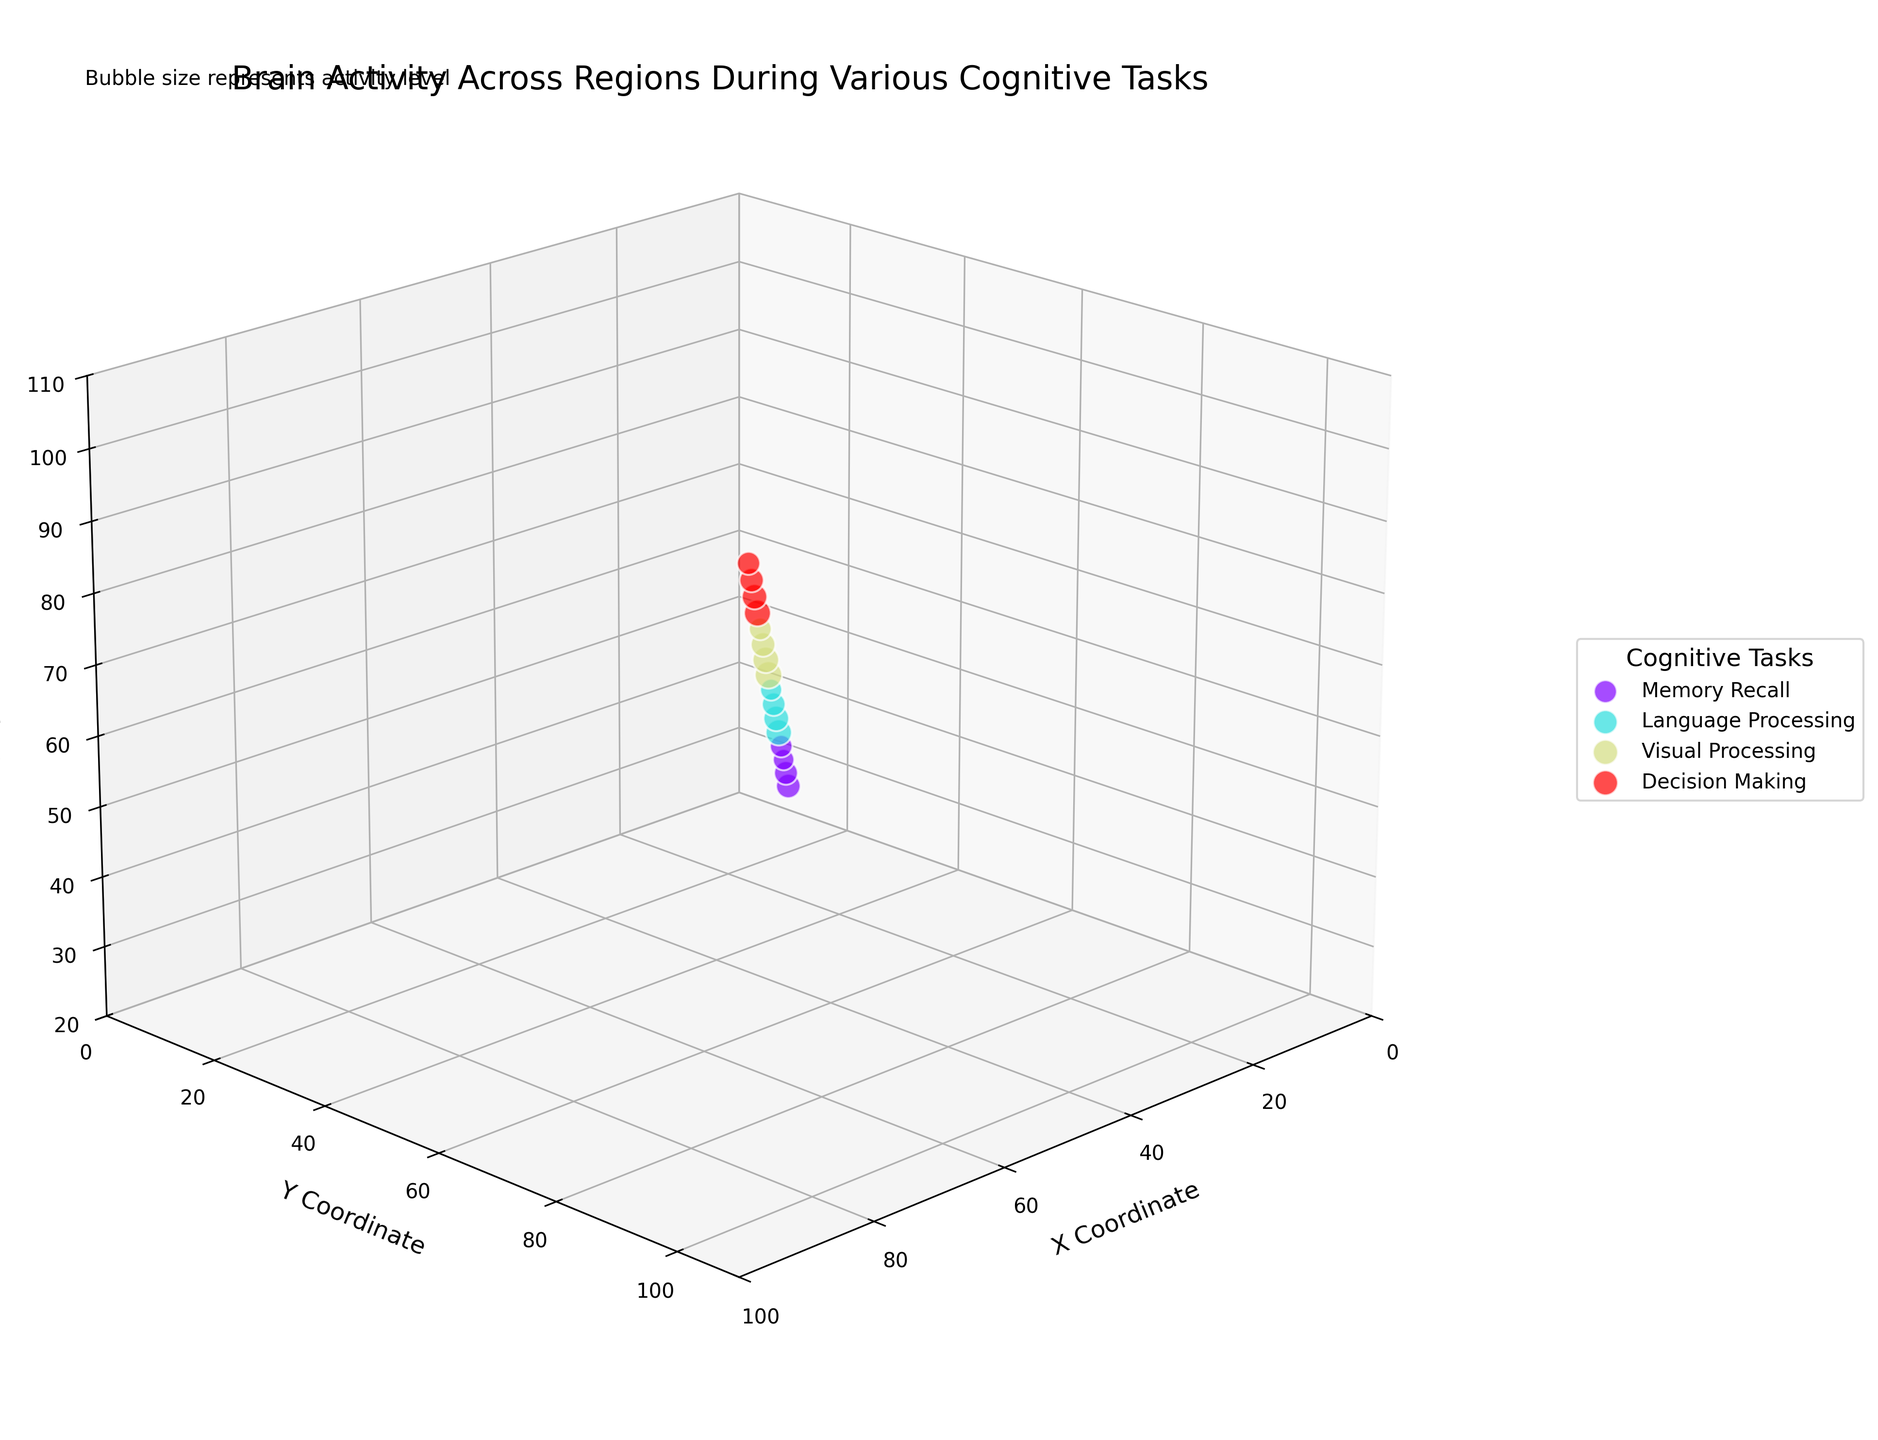What's the title of the figure? The title is located at the top of the figure and reads "Brain Activity Across Regions During Various Cognitive Tasks".
Answer: Brain Activity Across Regions During Various Cognitive Tasks What three axes are labeled on the plot? The three axes are labeled as "X Coordinate", "Y Coordinate", and "Z Coordinate", which can be found along the axes themselves in the figure.
Answer: X Coordinate, Y Coordinate, and Z Coordinate What task shows the highest activity level? By observing the bubble sizes in the scatter plot, the largest bubble represents the highest activity level. The bubble at (50, 60, 70) in the Visual Processing task with Occipital Lobe indicates the highest activity level of 9.1.
Answer: Visual Processing Which cognitive task has the most represented brain regions? By counting the bubbles for each cognitive task, the tasks are Memory Recall with 4 regions, Language Processing with 4 regions, Visual Processing with 4 regions, and Decision Making with 4 regions. All tasks are equally represented with 4 regions each.
Answer: Memory Recall, Language Processing, Visual Processing, and Decision Making Which specific region in the Prefrontal Cortex has higher activity, Memory Recall or Decision Making? By comparing the Activity values, Memory Recall has an activity level of 6.8 in the Prefrontal Cortex, while Decision Making has 8.7 in the same region. Since 8.7 > 6.8, the Prefrontal Cortex during Decision Making shows higher activity.
Answer: Decision Making What's the average activity level for the Temporal Lobe across different tasks? By summing up the activity levels of the Temporal Lobe across all tasks [(6.1 for Memory Recall) + (5.8 for Language Processing) + (6.2 for Visual Processing)] and dividing by the number of occurrences (3), the average activity level is (6.1 + 5.8 + 6.2) / 3 = 18.1 / 3 = 6.03.
Answer: 6.03 Which brain region is associated with the Memory Recall task at coordinates (20, 30, 40)? The coordinates (20, 30, 40) correspond to the Amygdala region for the Memory Recall task as per the data provided.
Answer: Amygdala Which task has bubbles with an average activity level closest to 7? By calculating the average for each task: Memory Recall (7.2 + 6.8 + 5.5 + 6.1) / 4 = 6.4, Language Processing (8.3 + 7.9 + 6.7 + 5.8) / 4 = 7.175, Visual Processing (9.1 + 8.5 + 7.3 + 6.2) / 4 = 7.775, and Decision Making (8.7 + 7.8 + 7.1 + 6.5) / 4 = 7.525. Language Processing's average activity of 7.175 is closest to 7.
Answer: Language Processing 